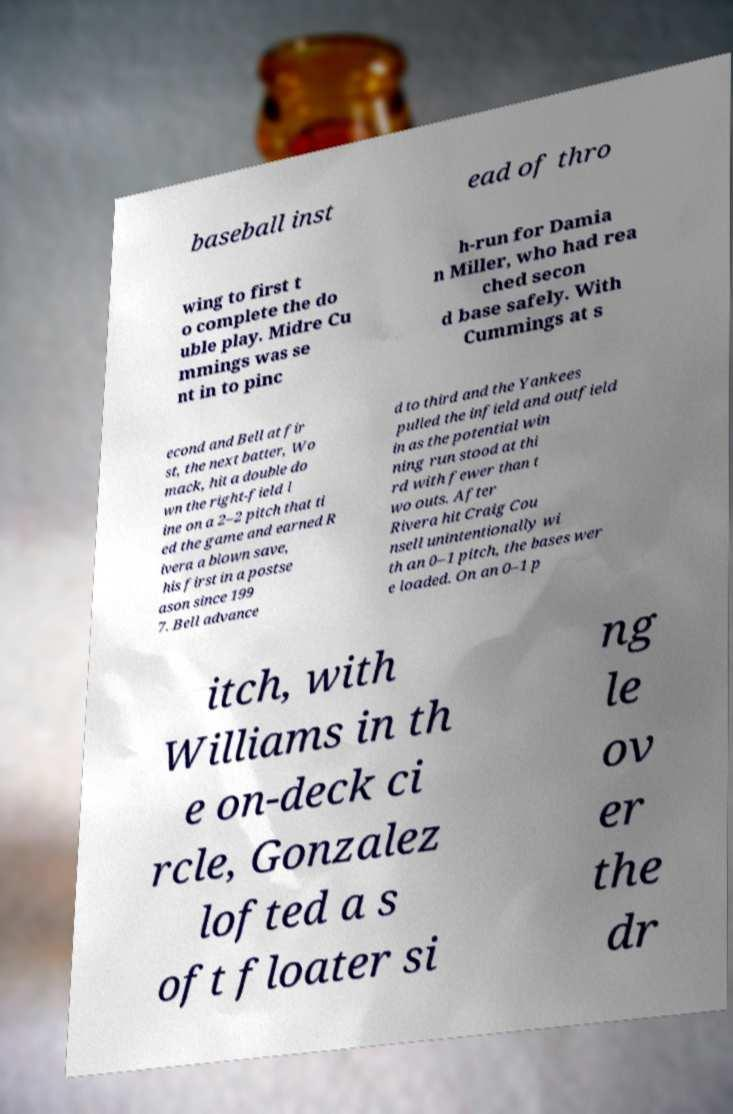Could you extract and type out the text from this image? baseball inst ead of thro wing to first t o complete the do uble play. Midre Cu mmings was se nt in to pinc h-run for Damia n Miller, who had rea ched secon d base safely. With Cummings at s econd and Bell at fir st, the next batter, Wo mack, hit a double do wn the right-field l ine on a 2–2 pitch that ti ed the game and earned R ivera a blown save, his first in a postse ason since 199 7. Bell advance d to third and the Yankees pulled the infield and outfield in as the potential win ning run stood at thi rd with fewer than t wo outs. After Rivera hit Craig Cou nsell unintentionally wi th an 0–1 pitch, the bases wer e loaded. On an 0–1 p itch, with Williams in th e on-deck ci rcle, Gonzalez lofted a s oft floater si ng le ov er the dr 